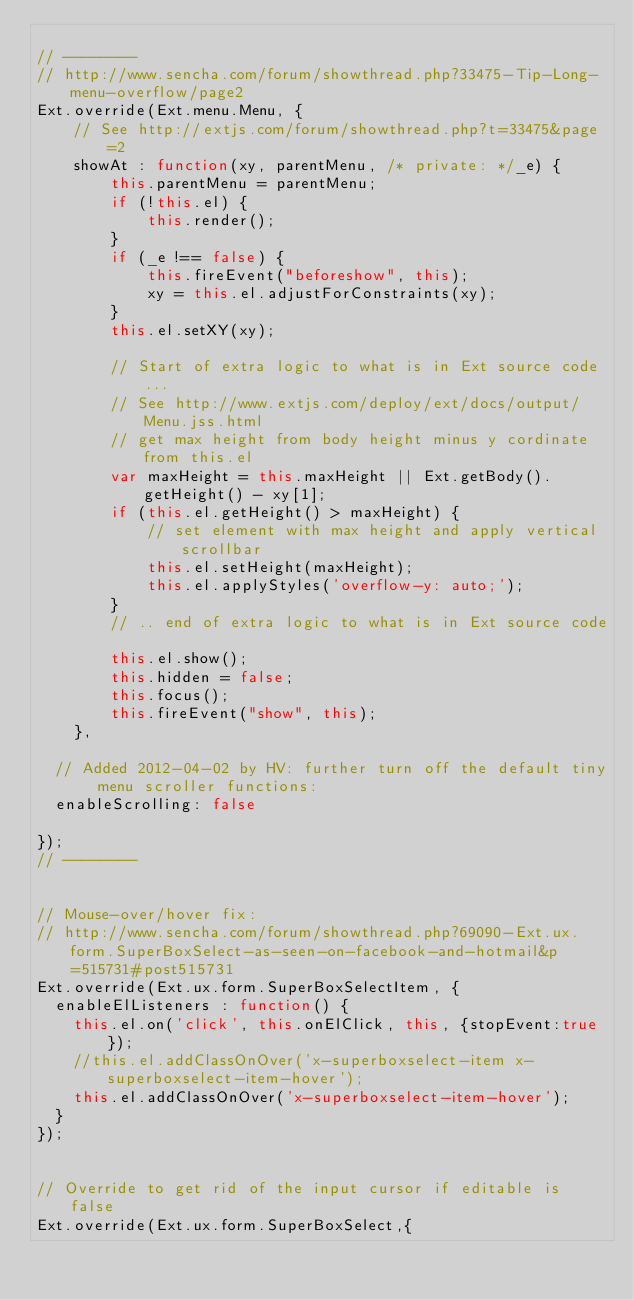Convert code to text. <code><loc_0><loc_0><loc_500><loc_500><_JavaScript_>
// --------
// http://www.sencha.com/forum/showthread.php?33475-Tip-Long-menu-overflow/page2
Ext.override(Ext.menu.Menu, {
    // See http://extjs.com/forum/showthread.php?t=33475&page=2
    showAt : function(xy, parentMenu, /* private: */_e) {
        this.parentMenu = parentMenu;
        if (!this.el) {
            this.render();
        }
        if (_e !== false) {
            this.fireEvent("beforeshow", this);
            xy = this.el.adjustForConstraints(xy);
        }
        this.el.setXY(xy);

        // Start of extra logic to what is in Ext source code...
        // See http://www.extjs.com/deploy/ext/docs/output/Menu.jss.html
        // get max height from body height minus y cordinate from this.el
        var maxHeight = this.maxHeight || Ext.getBody().getHeight() - xy[1];
        if (this.el.getHeight() > maxHeight) {
            // set element with max height and apply vertical scrollbar
            this.el.setHeight(maxHeight);
            this.el.applyStyles('overflow-y: auto;');
        }
        // .. end of extra logic to what is in Ext source code

        this.el.show();
        this.hidden = false;
        this.focus();
        this.fireEvent("show", this);
    },
	 
	// Added 2012-04-02 by HV: further turn off the default tiny menu scroller functions:
	enableScrolling: false
	 
});
// --------


// Mouse-over/hover fix:
// http://www.sencha.com/forum/showthread.php?69090-Ext.ux.form.SuperBoxSelect-as-seen-on-facebook-and-hotmail&p=515731#post515731
Ext.override(Ext.ux.form.SuperBoxSelectItem, {
	enableElListeners : function() {
		this.el.on('click', this.onElClick, this, {stopEvent:true});
		//this.el.addClassOnOver('x-superboxselect-item x-superboxselect-item-hover');
		this.el.addClassOnOver('x-superboxselect-item-hover');
	}
});


// Override to get rid of the input cursor if editable is false
Ext.override(Ext.ux.form.SuperBoxSelect,{</code> 